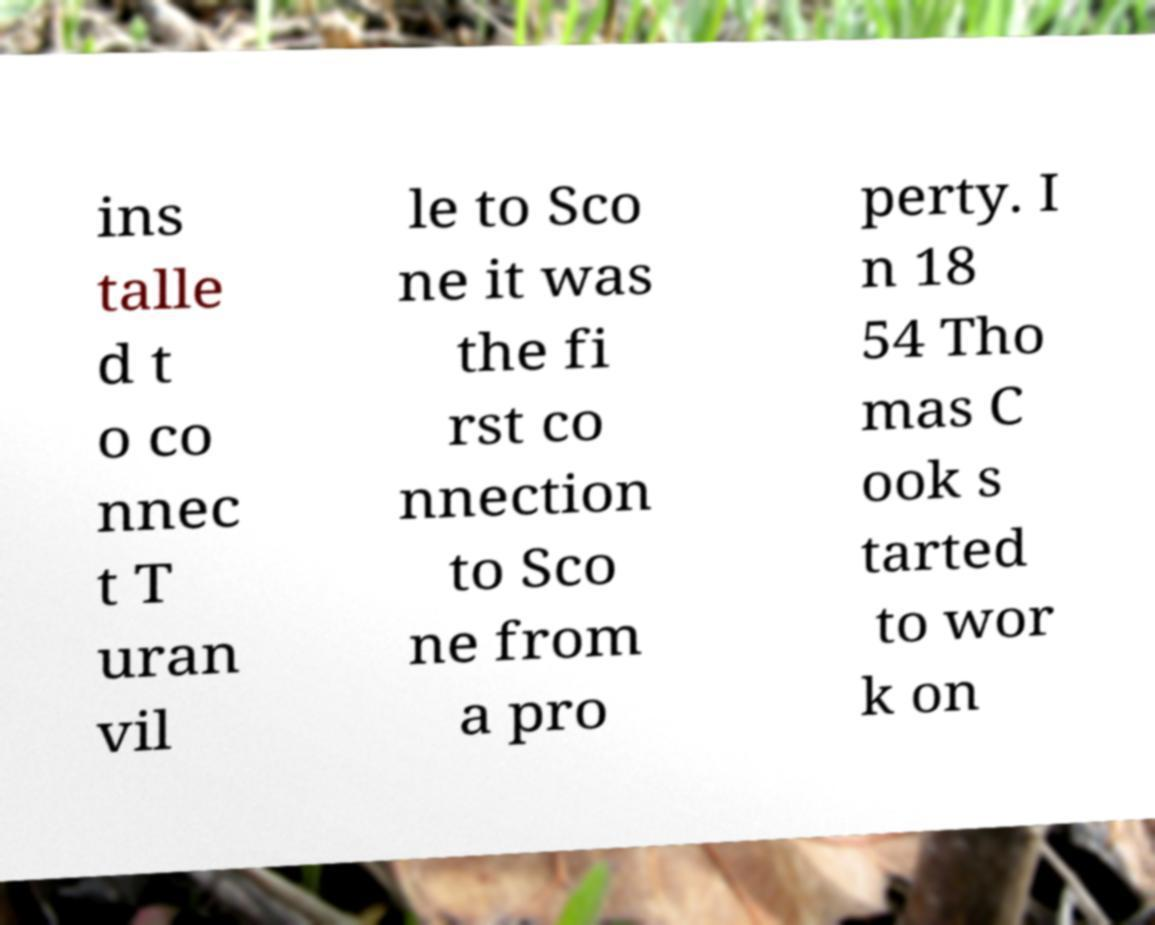Could you assist in decoding the text presented in this image and type it out clearly? ins talle d t o co nnec t T uran vil le to Sco ne it was the fi rst co nnection to Sco ne from a pro perty. I n 18 54 Tho mas C ook s tarted to wor k on 